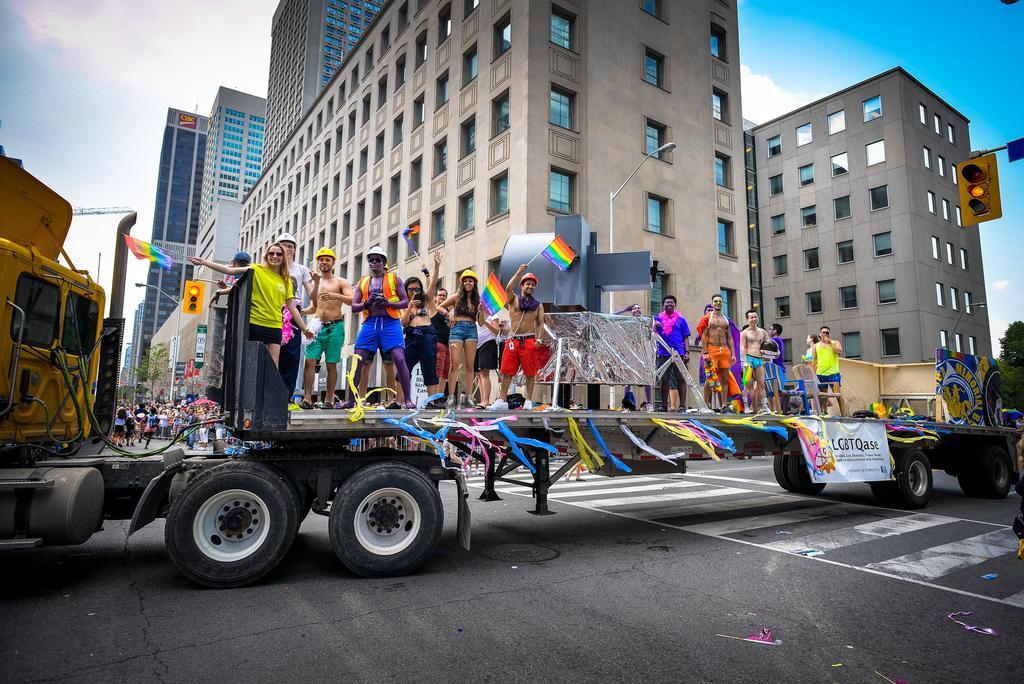Describe this image in one or two sentences. In this image we can see a group of persons standing on a vehicle and among them there are few persons holding flags. Behinds the persons there are few buildings, persons and trees. On the right side, we can see the traffic lights and the trees. At the top we can see the sky. 